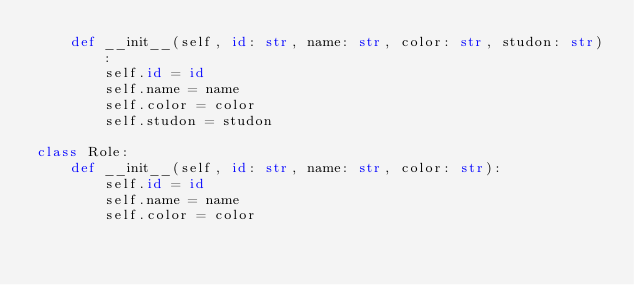<code> <loc_0><loc_0><loc_500><loc_500><_Python_>    def __init__(self, id: str, name: str, color: str, studon: str):
        self.id = id
        self.name = name
        self.color = color
        self.studon = studon

class Role:
    def __init__(self, id: str, name: str, color: str):
        self.id = id
        self.name = name
        self.color = color</code> 